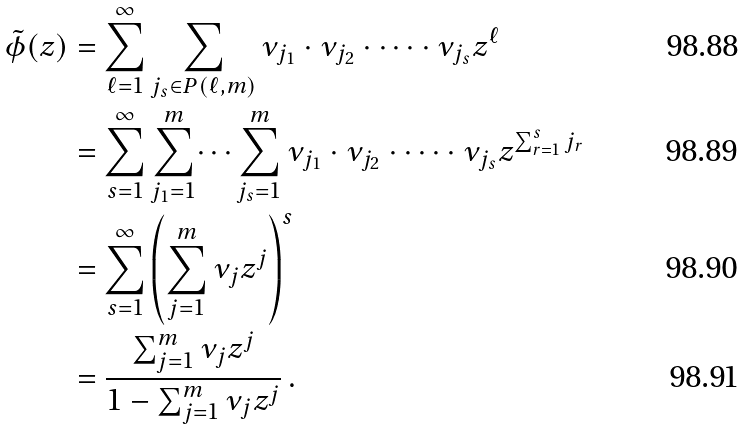Convert formula to latex. <formula><loc_0><loc_0><loc_500><loc_500>\tilde { \phi } ( z ) & = \sum _ { \ell = 1 } ^ { \infty } \sum _ { { j _ { s } } \in P ( \ell , m ) } \nu _ { j _ { 1 } } \cdot \nu _ { j _ { 2 } } \cdot \dots \cdot \nu _ { j _ { s } } z ^ { \ell } \\ & = \sum _ { s = 1 } ^ { \infty } \sum _ { j _ { 1 } = 1 } ^ { m } \dots \sum _ { j _ { s } = 1 } ^ { m } \nu _ { j _ { 1 } } \cdot \nu _ { j _ { 2 } } \cdot \dots \cdot \nu _ { j _ { s } } z ^ { \sum _ { r = 1 } ^ { s } j _ { r } } \\ & = \sum _ { s = 1 } ^ { \infty } \left ( \sum _ { j = 1 } ^ { m } \nu _ { j } z ^ { j } \right ) ^ { s } \\ & = \frac { \sum _ { j = 1 } ^ { m } \nu _ { j } z ^ { j } } { 1 - \sum _ { j = 1 } ^ { m } \nu _ { j } z ^ { j } } \, .</formula> 